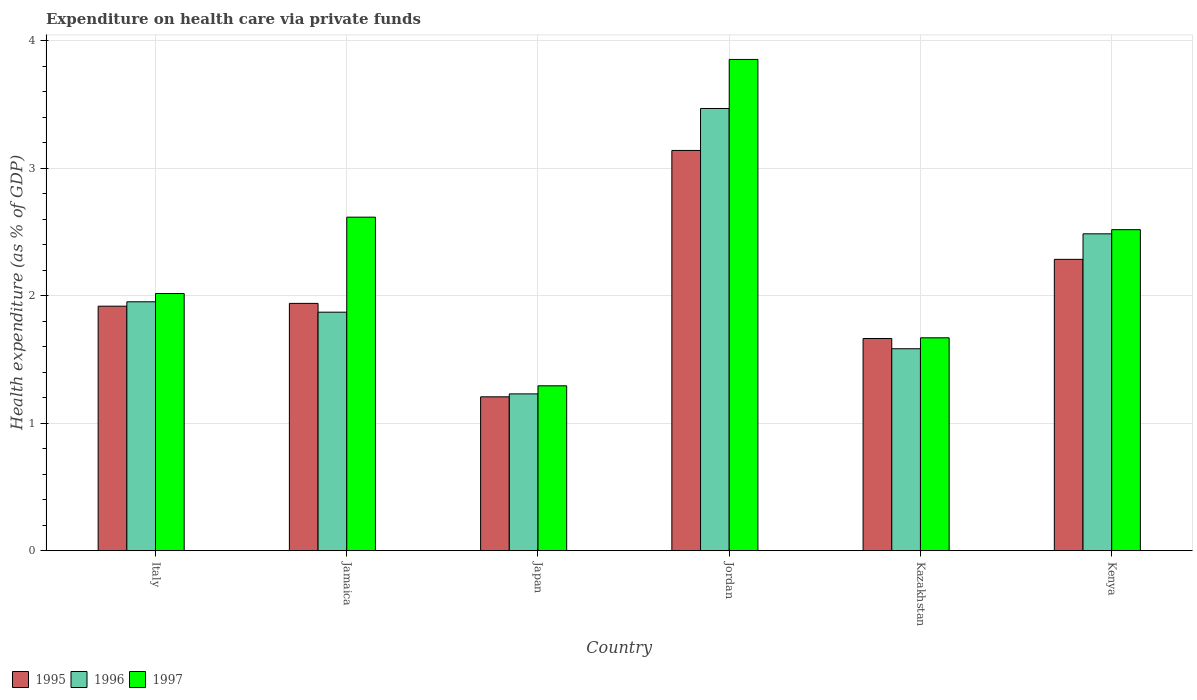Are the number of bars per tick equal to the number of legend labels?
Offer a very short reply. Yes. Are the number of bars on each tick of the X-axis equal?
Provide a succinct answer. Yes. How many bars are there on the 4th tick from the left?
Your response must be concise. 3. What is the label of the 5th group of bars from the left?
Ensure brevity in your answer.  Kazakhstan. What is the expenditure made on health care in 1997 in Kenya?
Ensure brevity in your answer.  2.52. Across all countries, what is the maximum expenditure made on health care in 1995?
Keep it short and to the point. 3.14. Across all countries, what is the minimum expenditure made on health care in 1996?
Provide a short and direct response. 1.23. In which country was the expenditure made on health care in 1997 maximum?
Your answer should be very brief. Jordan. What is the total expenditure made on health care in 1997 in the graph?
Make the answer very short. 13.97. What is the difference between the expenditure made on health care in 1996 in Italy and that in Japan?
Your answer should be compact. 0.72. What is the difference between the expenditure made on health care in 1997 in Kenya and the expenditure made on health care in 1995 in Japan?
Offer a terse response. 1.31. What is the average expenditure made on health care in 1997 per country?
Offer a terse response. 2.33. What is the difference between the expenditure made on health care of/in 1996 and expenditure made on health care of/in 1995 in Jordan?
Offer a very short reply. 0.33. In how many countries, is the expenditure made on health care in 1997 greater than 2.2 %?
Provide a short and direct response. 3. What is the ratio of the expenditure made on health care in 1997 in Italy to that in Jamaica?
Your answer should be very brief. 0.77. Is the expenditure made on health care in 1997 in Italy less than that in Kenya?
Make the answer very short. Yes. Is the difference between the expenditure made on health care in 1996 in Jamaica and Japan greater than the difference between the expenditure made on health care in 1995 in Jamaica and Japan?
Your response must be concise. No. What is the difference between the highest and the second highest expenditure made on health care in 1995?
Give a very brief answer. -0.35. What is the difference between the highest and the lowest expenditure made on health care in 1995?
Keep it short and to the point. 1.93. In how many countries, is the expenditure made on health care in 1995 greater than the average expenditure made on health care in 1995 taken over all countries?
Your answer should be very brief. 2. Is the sum of the expenditure made on health care in 1995 in Jamaica and Japan greater than the maximum expenditure made on health care in 1996 across all countries?
Provide a succinct answer. No. How many bars are there?
Your answer should be compact. 18. Are all the bars in the graph horizontal?
Make the answer very short. No. How many countries are there in the graph?
Keep it short and to the point. 6. Does the graph contain any zero values?
Provide a succinct answer. No. Does the graph contain grids?
Offer a terse response. Yes. How many legend labels are there?
Give a very brief answer. 3. How are the legend labels stacked?
Keep it short and to the point. Horizontal. What is the title of the graph?
Keep it short and to the point. Expenditure on health care via private funds. What is the label or title of the X-axis?
Make the answer very short. Country. What is the label or title of the Y-axis?
Give a very brief answer. Health expenditure (as % of GDP). What is the Health expenditure (as % of GDP) in 1995 in Italy?
Make the answer very short. 1.92. What is the Health expenditure (as % of GDP) in 1996 in Italy?
Your answer should be compact. 1.95. What is the Health expenditure (as % of GDP) of 1997 in Italy?
Your answer should be very brief. 2.02. What is the Health expenditure (as % of GDP) of 1995 in Jamaica?
Provide a short and direct response. 1.94. What is the Health expenditure (as % of GDP) in 1996 in Jamaica?
Offer a very short reply. 1.87. What is the Health expenditure (as % of GDP) in 1997 in Jamaica?
Ensure brevity in your answer.  2.62. What is the Health expenditure (as % of GDP) of 1995 in Japan?
Give a very brief answer. 1.21. What is the Health expenditure (as % of GDP) of 1996 in Japan?
Keep it short and to the point. 1.23. What is the Health expenditure (as % of GDP) in 1997 in Japan?
Keep it short and to the point. 1.29. What is the Health expenditure (as % of GDP) of 1995 in Jordan?
Your answer should be compact. 3.14. What is the Health expenditure (as % of GDP) in 1996 in Jordan?
Make the answer very short. 3.47. What is the Health expenditure (as % of GDP) of 1997 in Jordan?
Provide a succinct answer. 3.85. What is the Health expenditure (as % of GDP) of 1995 in Kazakhstan?
Give a very brief answer. 1.66. What is the Health expenditure (as % of GDP) in 1996 in Kazakhstan?
Keep it short and to the point. 1.58. What is the Health expenditure (as % of GDP) in 1997 in Kazakhstan?
Offer a terse response. 1.67. What is the Health expenditure (as % of GDP) of 1995 in Kenya?
Provide a short and direct response. 2.29. What is the Health expenditure (as % of GDP) in 1996 in Kenya?
Your response must be concise. 2.49. What is the Health expenditure (as % of GDP) of 1997 in Kenya?
Offer a very short reply. 2.52. Across all countries, what is the maximum Health expenditure (as % of GDP) of 1995?
Keep it short and to the point. 3.14. Across all countries, what is the maximum Health expenditure (as % of GDP) of 1996?
Make the answer very short. 3.47. Across all countries, what is the maximum Health expenditure (as % of GDP) in 1997?
Your answer should be compact. 3.85. Across all countries, what is the minimum Health expenditure (as % of GDP) of 1995?
Keep it short and to the point. 1.21. Across all countries, what is the minimum Health expenditure (as % of GDP) in 1996?
Ensure brevity in your answer.  1.23. Across all countries, what is the minimum Health expenditure (as % of GDP) in 1997?
Keep it short and to the point. 1.29. What is the total Health expenditure (as % of GDP) in 1995 in the graph?
Your response must be concise. 12.15. What is the total Health expenditure (as % of GDP) of 1996 in the graph?
Your answer should be compact. 12.59. What is the total Health expenditure (as % of GDP) in 1997 in the graph?
Keep it short and to the point. 13.97. What is the difference between the Health expenditure (as % of GDP) of 1995 in Italy and that in Jamaica?
Ensure brevity in your answer.  -0.02. What is the difference between the Health expenditure (as % of GDP) in 1996 in Italy and that in Jamaica?
Provide a succinct answer. 0.08. What is the difference between the Health expenditure (as % of GDP) in 1997 in Italy and that in Jamaica?
Provide a short and direct response. -0.6. What is the difference between the Health expenditure (as % of GDP) of 1995 in Italy and that in Japan?
Offer a very short reply. 0.71. What is the difference between the Health expenditure (as % of GDP) of 1996 in Italy and that in Japan?
Offer a very short reply. 0.72. What is the difference between the Health expenditure (as % of GDP) of 1997 in Italy and that in Japan?
Your answer should be compact. 0.72. What is the difference between the Health expenditure (as % of GDP) of 1995 in Italy and that in Jordan?
Give a very brief answer. -1.22. What is the difference between the Health expenditure (as % of GDP) in 1996 in Italy and that in Jordan?
Make the answer very short. -1.52. What is the difference between the Health expenditure (as % of GDP) in 1997 in Italy and that in Jordan?
Ensure brevity in your answer.  -1.84. What is the difference between the Health expenditure (as % of GDP) in 1995 in Italy and that in Kazakhstan?
Provide a short and direct response. 0.25. What is the difference between the Health expenditure (as % of GDP) in 1996 in Italy and that in Kazakhstan?
Your answer should be compact. 0.37. What is the difference between the Health expenditure (as % of GDP) in 1997 in Italy and that in Kazakhstan?
Provide a succinct answer. 0.35. What is the difference between the Health expenditure (as % of GDP) of 1995 in Italy and that in Kenya?
Keep it short and to the point. -0.37. What is the difference between the Health expenditure (as % of GDP) of 1996 in Italy and that in Kenya?
Keep it short and to the point. -0.53. What is the difference between the Health expenditure (as % of GDP) of 1997 in Italy and that in Kenya?
Keep it short and to the point. -0.5. What is the difference between the Health expenditure (as % of GDP) of 1995 in Jamaica and that in Japan?
Ensure brevity in your answer.  0.73. What is the difference between the Health expenditure (as % of GDP) of 1996 in Jamaica and that in Japan?
Make the answer very short. 0.64. What is the difference between the Health expenditure (as % of GDP) of 1997 in Jamaica and that in Japan?
Your response must be concise. 1.32. What is the difference between the Health expenditure (as % of GDP) of 1995 in Jamaica and that in Jordan?
Keep it short and to the point. -1.2. What is the difference between the Health expenditure (as % of GDP) in 1996 in Jamaica and that in Jordan?
Offer a very short reply. -1.6. What is the difference between the Health expenditure (as % of GDP) in 1997 in Jamaica and that in Jordan?
Keep it short and to the point. -1.24. What is the difference between the Health expenditure (as % of GDP) in 1995 in Jamaica and that in Kazakhstan?
Keep it short and to the point. 0.28. What is the difference between the Health expenditure (as % of GDP) in 1996 in Jamaica and that in Kazakhstan?
Offer a very short reply. 0.29. What is the difference between the Health expenditure (as % of GDP) in 1997 in Jamaica and that in Kazakhstan?
Provide a succinct answer. 0.95. What is the difference between the Health expenditure (as % of GDP) of 1995 in Jamaica and that in Kenya?
Your answer should be compact. -0.35. What is the difference between the Health expenditure (as % of GDP) of 1996 in Jamaica and that in Kenya?
Keep it short and to the point. -0.61. What is the difference between the Health expenditure (as % of GDP) of 1997 in Jamaica and that in Kenya?
Your response must be concise. 0.1. What is the difference between the Health expenditure (as % of GDP) of 1995 in Japan and that in Jordan?
Your answer should be very brief. -1.93. What is the difference between the Health expenditure (as % of GDP) in 1996 in Japan and that in Jordan?
Ensure brevity in your answer.  -2.24. What is the difference between the Health expenditure (as % of GDP) of 1997 in Japan and that in Jordan?
Your answer should be very brief. -2.56. What is the difference between the Health expenditure (as % of GDP) of 1995 in Japan and that in Kazakhstan?
Provide a short and direct response. -0.46. What is the difference between the Health expenditure (as % of GDP) of 1996 in Japan and that in Kazakhstan?
Offer a terse response. -0.35. What is the difference between the Health expenditure (as % of GDP) of 1997 in Japan and that in Kazakhstan?
Provide a succinct answer. -0.38. What is the difference between the Health expenditure (as % of GDP) in 1995 in Japan and that in Kenya?
Your answer should be compact. -1.08. What is the difference between the Health expenditure (as % of GDP) in 1996 in Japan and that in Kenya?
Your response must be concise. -1.26. What is the difference between the Health expenditure (as % of GDP) in 1997 in Japan and that in Kenya?
Your answer should be compact. -1.22. What is the difference between the Health expenditure (as % of GDP) in 1995 in Jordan and that in Kazakhstan?
Make the answer very short. 1.48. What is the difference between the Health expenditure (as % of GDP) of 1996 in Jordan and that in Kazakhstan?
Provide a short and direct response. 1.88. What is the difference between the Health expenditure (as % of GDP) in 1997 in Jordan and that in Kazakhstan?
Provide a succinct answer. 2.18. What is the difference between the Health expenditure (as % of GDP) in 1995 in Jordan and that in Kenya?
Ensure brevity in your answer.  0.85. What is the difference between the Health expenditure (as % of GDP) in 1996 in Jordan and that in Kenya?
Provide a succinct answer. 0.98. What is the difference between the Health expenditure (as % of GDP) in 1997 in Jordan and that in Kenya?
Ensure brevity in your answer.  1.34. What is the difference between the Health expenditure (as % of GDP) of 1995 in Kazakhstan and that in Kenya?
Give a very brief answer. -0.62. What is the difference between the Health expenditure (as % of GDP) in 1996 in Kazakhstan and that in Kenya?
Provide a short and direct response. -0.9. What is the difference between the Health expenditure (as % of GDP) in 1997 in Kazakhstan and that in Kenya?
Your answer should be very brief. -0.85. What is the difference between the Health expenditure (as % of GDP) of 1995 in Italy and the Health expenditure (as % of GDP) of 1996 in Jamaica?
Provide a succinct answer. 0.05. What is the difference between the Health expenditure (as % of GDP) of 1995 in Italy and the Health expenditure (as % of GDP) of 1997 in Jamaica?
Ensure brevity in your answer.  -0.7. What is the difference between the Health expenditure (as % of GDP) of 1996 in Italy and the Health expenditure (as % of GDP) of 1997 in Jamaica?
Make the answer very short. -0.66. What is the difference between the Health expenditure (as % of GDP) in 1995 in Italy and the Health expenditure (as % of GDP) in 1996 in Japan?
Provide a short and direct response. 0.69. What is the difference between the Health expenditure (as % of GDP) in 1995 in Italy and the Health expenditure (as % of GDP) in 1997 in Japan?
Your response must be concise. 0.62. What is the difference between the Health expenditure (as % of GDP) of 1996 in Italy and the Health expenditure (as % of GDP) of 1997 in Japan?
Make the answer very short. 0.66. What is the difference between the Health expenditure (as % of GDP) in 1995 in Italy and the Health expenditure (as % of GDP) in 1996 in Jordan?
Provide a succinct answer. -1.55. What is the difference between the Health expenditure (as % of GDP) in 1995 in Italy and the Health expenditure (as % of GDP) in 1997 in Jordan?
Give a very brief answer. -1.94. What is the difference between the Health expenditure (as % of GDP) in 1996 in Italy and the Health expenditure (as % of GDP) in 1997 in Jordan?
Your answer should be compact. -1.9. What is the difference between the Health expenditure (as % of GDP) of 1995 in Italy and the Health expenditure (as % of GDP) of 1996 in Kazakhstan?
Give a very brief answer. 0.33. What is the difference between the Health expenditure (as % of GDP) in 1995 in Italy and the Health expenditure (as % of GDP) in 1997 in Kazakhstan?
Your answer should be compact. 0.25. What is the difference between the Health expenditure (as % of GDP) in 1996 in Italy and the Health expenditure (as % of GDP) in 1997 in Kazakhstan?
Provide a succinct answer. 0.28. What is the difference between the Health expenditure (as % of GDP) of 1995 in Italy and the Health expenditure (as % of GDP) of 1996 in Kenya?
Offer a very short reply. -0.57. What is the difference between the Health expenditure (as % of GDP) in 1995 in Italy and the Health expenditure (as % of GDP) in 1997 in Kenya?
Your answer should be very brief. -0.6. What is the difference between the Health expenditure (as % of GDP) in 1996 in Italy and the Health expenditure (as % of GDP) in 1997 in Kenya?
Give a very brief answer. -0.57. What is the difference between the Health expenditure (as % of GDP) of 1995 in Jamaica and the Health expenditure (as % of GDP) of 1996 in Japan?
Your response must be concise. 0.71. What is the difference between the Health expenditure (as % of GDP) in 1995 in Jamaica and the Health expenditure (as % of GDP) in 1997 in Japan?
Your answer should be compact. 0.65. What is the difference between the Health expenditure (as % of GDP) of 1996 in Jamaica and the Health expenditure (as % of GDP) of 1997 in Japan?
Your response must be concise. 0.58. What is the difference between the Health expenditure (as % of GDP) of 1995 in Jamaica and the Health expenditure (as % of GDP) of 1996 in Jordan?
Keep it short and to the point. -1.53. What is the difference between the Health expenditure (as % of GDP) of 1995 in Jamaica and the Health expenditure (as % of GDP) of 1997 in Jordan?
Provide a succinct answer. -1.91. What is the difference between the Health expenditure (as % of GDP) in 1996 in Jamaica and the Health expenditure (as % of GDP) in 1997 in Jordan?
Ensure brevity in your answer.  -1.98. What is the difference between the Health expenditure (as % of GDP) in 1995 in Jamaica and the Health expenditure (as % of GDP) in 1996 in Kazakhstan?
Ensure brevity in your answer.  0.36. What is the difference between the Health expenditure (as % of GDP) in 1995 in Jamaica and the Health expenditure (as % of GDP) in 1997 in Kazakhstan?
Offer a very short reply. 0.27. What is the difference between the Health expenditure (as % of GDP) of 1996 in Jamaica and the Health expenditure (as % of GDP) of 1997 in Kazakhstan?
Ensure brevity in your answer.  0.2. What is the difference between the Health expenditure (as % of GDP) of 1995 in Jamaica and the Health expenditure (as % of GDP) of 1996 in Kenya?
Make the answer very short. -0.55. What is the difference between the Health expenditure (as % of GDP) in 1995 in Jamaica and the Health expenditure (as % of GDP) in 1997 in Kenya?
Offer a terse response. -0.58. What is the difference between the Health expenditure (as % of GDP) of 1996 in Jamaica and the Health expenditure (as % of GDP) of 1997 in Kenya?
Your response must be concise. -0.65. What is the difference between the Health expenditure (as % of GDP) of 1995 in Japan and the Health expenditure (as % of GDP) of 1996 in Jordan?
Provide a short and direct response. -2.26. What is the difference between the Health expenditure (as % of GDP) in 1995 in Japan and the Health expenditure (as % of GDP) in 1997 in Jordan?
Offer a terse response. -2.65. What is the difference between the Health expenditure (as % of GDP) in 1996 in Japan and the Health expenditure (as % of GDP) in 1997 in Jordan?
Your response must be concise. -2.62. What is the difference between the Health expenditure (as % of GDP) of 1995 in Japan and the Health expenditure (as % of GDP) of 1996 in Kazakhstan?
Ensure brevity in your answer.  -0.38. What is the difference between the Health expenditure (as % of GDP) of 1995 in Japan and the Health expenditure (as % of GDP) of 1997 in Kazakhstan?
Ensure brevity in your answer.  -0.46. What is the difference between the Health expenditure (as % of GDP) of 1996 in Japan and the Health expenditure (as % of GDP) of 1997 in Kazakhstan?
Your answer should be very brief. -0.44. What is the difference between the Health expenditure (as % of GDP) of 1995 in Japan and the Health expenditure (as % of GDP) of 1996 in Kenya?
Provide a succinct answer. -1.28. What is the difference between the Health expenditure (as % of GDP) in 1995 in Japan and the Health expenditure (as % of GDP) in 1997 in Kenya?
Offer a very short reply. -1.31. What is the difference between the Health expenditure (as % of GDP) in 1996 in Japan and the Health expenditure (as % of GDP) in 1997 in Kenya?
Your answer should be very brief. -1.29. What is the difference between the Health expenditure (as % of GDP) in 1995 in Jordan and the Health expenditure (as % of GDP) in 1996 in Kazakhstan?
Ensure brevity in your answer.  1.56. What is the difference between the Health expenditure (as % of GDP) of 1995 in Jordan and the Health expenditure (as % of GDP) of 1997 in Kazakhstan?
Your response must be concise. 1.47. What is the difference between the Health expenditure (as % of GDP) in 1996 in Jordan and the Health expenditure (as % of GDP) in 1997 in Kazakhstan?
Ensure brevity in your answer.  1.8. What is the difference between the Health expenditure (as % of GDP) of 1995 in Jordan and the Health expenditure (as % of GDP) of 1996 in Kenya?
Provide a succinct answer. 0.65. What is the difference between the Health expenditure (as % of GDP) of 1995 in Jordan and the Health expenditure (as % of GDP) of 1997 in Kenya?
Offer a terse response. 0.62. What is the difference between the Health expenditure (as % of GDP) of 1996 in Jordan and the Health expenditure (as % of GDP) of 1997 in Kenya?
Your answer should be compact. 0.95. What is the difference between the Health expenditure (as % of GDP) in 1995 in Kazakhstan and the Health expenditure (as % of GDP) in 1996 in Kenya?
Offer a terse response. -0.82. What is the difference between the Health expenditure (as % of GDP) of 1995 in Kazakhstan and the Health expenditure (as % of GDP) of 1997 in Kenya?
Ensure brevity in your answer.  -0.85. What is the difference between the Health expenditure (as % of GDP) of 1996 in Kazakhstan and the Health expenditure (as % of GDP) of 1997 in Kenya?
Your answer should be very brief. -0.93. What is the average Health expenditure (as % of GDP) of 1995 per country?
Provide a succinct answer. 2.03. What is the average Health expenditure (as % of GDP) of 1996 per country?
Keep it short and to the point. 2.1. What is the average Health expenditure (as % of GDP) in 1997 per country?
Provide a short and direct response. 2.33. What is the difference between the Health expenditure (as % of GDP) in 1995 and Health expenditure (as % of GDP) in 1996 in Italy?
Your response must be concise. -0.03. What is the difference between the Health expenditure (as % of GDP) in 1995 and Health expenditure (as % of GDP) in 1997 in Italy?
Make the answer very short. -0.1. What is the difference between the Health expenditure (as % of GDP) of 1996 and Health expenditure (as % of GDP) of 1997 in Italy?
Offer a very short reply. -0.06. What is the difference between the Health expenditure (as % of GDP) in 1995 and Health expenditure (as % of GDP) in 1996 in Jamaica?
Offer a very short reply. 0.07. What is the difference between the Health expenditure (as % of GDP) of 1995 and Health expenditure (as % of GDP) of 1997 in Jamaica?
Your response must be concise. -0.68. What is the difference between the Health expenditure (as % of GDP) of 1996 and Health expenditure (as % of GDP) of 1997 in Jamaica?
Ensure brevity in your answer.  -0.75. What is the difference between the Health expenditure (as % of GDP) in 1995 and Health expenditure (as % of GDP) in 1996 in Japan?
Your answer should be very brief. -0.02. What is the difference between the Health expenditure (as % of GDP) in 1995 and Health expenditure (as % of GDP) in 1997 in Japan?
Your answer should be compact. -0.09. What is the difference between the Health expenditure (as % of GDP) of 1996 and Health expenditure (as % of GDP) of 1997 in Japan?
Your answer should be compact. -0.06. What is the difference between the Health expenditure (as % of GDP) of 1995 and Health expenditure (as % of GDP) of 1996 in Jordan?
Offer a terse response. -0.33. What is the difference between the Health expenditure (as % of GDP) in 1995 and Health expenditure (as % of GDP) in 1997 in Jordan?
Your answer should be very brief. -0.71. What is the difference between the Health expenditure (as % of GDP) of 1996 and Health expenditure (as % of GDP) of 1997 in Jordan?
Offer a terse response. -0.38. What is the difference between the Health expenditure (as % of GDP) of 1995 and Health expenditure (as % of GDP) of 1996 in Kazakhstan?
Make the answer very short. 0.08. What is the difference between the Health expenditure (as % of GDP) of 1995 and Health expenditure (as % of GDP) of 1997 in Kazakhstan?
Give a very brief answer. -0.01. What is the difference between the Health expenditure (as % of GDP) in 1996 and Health expenditure (as % of GDP) in 1997 in Kazakhstan?
Provide a succinct answer. -0.09. What is the difference between the Health expenditure (as % of GDP) in 1995 and Health expenditure (as % of GDP) in 1996 in Kenya?
Provide a succinct answer. -0.2. What is the difference between the Health expenditure (as % of GDP) in 1995 and Health expenditure (as % of GDP) in 1997 in Kenya?
Provide a short and direct response. -0.23. What is the difference between the Health expenditure (as % of GDP) of 1996 and Health expenditure (as % of GDP) of 1997 in Kenya?
Your response must be concise. -0.03. What is the ratio of the Health expenditure (as % of GDP) in 1995 in Italy to that in Jamaica?
Ensure brevity in your answer.  0.99. What is the ratio of the Health expenditure (as % of GDP) of 1996 in Italy to that in Jamaica?
Your response must be concise. 1.04. What is the ratio of the Health expenditure (as % of GDP) of 1997 in Italy to that in Jamaica?
Offer a very short reply. 0.77. What is the ratio of the Health expenditure (as % of GDP) of 1995 in Italy to that in Japan?
Give a very brief answer. 1.59. What is the ratio of the Health expenditure (as % of GDP) of 1996 in Italy to that in Japan?
Your response must be concise. 1.59. What is the ratio of the Health expenditure (as % of GDP) in 1997 in Italy to that in Japan?
Offer a terse response. 1.56. What is the ratio of the Health expenditure (as % of GDP) of 1995 in Italy to that in Jordan?
Your response must be concise. 0.61. What is the ratio of the Health expenditure (as % of GDP) in 1996 in Italy to that in Jordan?
Your answer should be very brief. 0.56. What is the ratio of the Health expenditure (as % of GDP) in 1997 in Italy to that in Jordan?
Your response must be concise. 0.52. What is the ratio of the Health expenditure (as % of GDP) in 1995 in Italy to that in Kazakhstan?
Your answer should be very brief. 1.15. What is the ratio of the Health expenditure (as % of GDP) of 1996 in Italy to that in Kazakhstan?
Offer a very short reply. 1.23. What is the ratio of the Health expenditure (as % of GDP) of 1997 in Italy to that in Kazakhstan?
Your answer should be compact. 1.21. What is the ratio of the Health expenditure (as % of GDP) of 1995 in Italy to that in Kenya?
Your answer should be very brief. 0.84. What is the ratio of the Health expenditure (as % of GDP) in 1996 in Italy to that in Kenya?
Your answer should be compact. 0.79. What is the ratio of the Health expenditure (as % of GDP) of 1997 in Italy to that in Kenya?
Offer a very short reply. 0.8. What is the ratio of the Health expenditure (as % of GDP) of 1995 in Jamaica to that in Japan?
Provide a short and direct response. 1.61. What is the ratio of the Health expenditure (as % of GDP) of 1996 in Jamaica to that in Japan?
Your answer should be compact. 1.52. What is the ratio of the Health expenditure (as % of GDP) in 1997 in Jamaica to that in Japan?
Ensure brevity in your answer.  2.02. What is the ratio of the Health expenditure (as % of GDP) of 1995 in Jamaica to that in Jordan?
Give a very brief answer. 0.62. What is the ratio of the Health expenditure (as % of GDP) in 1996 in Jamaica to that in Jordan?
Provide a short and direct response. 0.54. What is the ratio of the Health expenditure (as % of GDP) of 1997 in Jamaica to that in Jordan?
Ensure brevity in your answer.  0.68. What is the ratio of the Health expenditure (as % of GDP) in 1995 in Jamaica to that in Kazakhstan?
Your answer should be very brief. 1.17. What is the ratio of the Health expenditure (as % of GDP) of 1996 in Jamaica to that in Kazakhstan?
Ensure brevity in your answer.  1.18. What is the ratio of the Health expenditure (as % of GDP) in 1997 in Jamaica to that in Kazakhstan?
Provide a succinct answer. 1.57. What is the ratio of the Health expenditure (as % of GDP) of 1995 in Jamaica to that in Kenya?
Your answer should be very brief. 0.85. What is the ratio of the Health expenditure (as % of GDP) of 1996 in Jamaica to that in Kenya?
Your response must be concise. 0.75. What is the ratio of the Health expenditure (as % of GDP) of 1997 in Jamaica to that in Kenya?
Your response must be concise. 1.04. What is the ratio of the Health expenditure (as % of GDP) in 1995 in Japan to that in Jordan?
Your response must be concise. 0.38. What is the ratio of the Health expenditure (as % of GDP) in 1996 in Japan to that in Jordan?
Keep it short and to the point. 0.35. What is the ratio of the Health expenditure (as % of GDP) of 1997 in Japan to that in Jordan?
Give a very brief answer. 0.34. What is the ratio of the Health expenditure (as % of GDP) of 1995 in Japan to that in Kazakhstan?
Your answer should be compact. 0.73. What is the ratio of the Health expenditure (as % of GDP) in 1996 in Japan to that in Kazakhstan?
Your answer should be compact. 0.78. What is the ratio of the Health expenditure (as % of GDP) of 1997 in Japan to that in Kazakhstan?
Offer a very short reply. 0.77. What is the ratio of the Health expenditure (as % of GDP) of 1995 in Japan to that in Kenya?
Give a very brief answer. 0.53. What is the ratio of the Health expenditure (as % of GDP) of 1996 in Japan to that in Kenya?
Make the answer very short. 0.49. What is the ratio of the Health expenditure (as % of GDP) of 1997 in Japan to that in Kenya?
Ensure brevity in your answer.  0.51. What is the ratio of the Health expenditure (as % of GDP) in 1995 in Jordan to that in Kazakhstan?
Offer a terse response. 1.89. What is the ratio of the Health expenditure (as % of GDP) in 1996 in Jordan to that in Kazakhstan?
Provide a short and direct response. 2.19. What is the ratio of the Health expenditure (as % of GDP) in 1997 in Jordan to that in Kazakhstan?
Your answer should be compact. 2.31. What is the ratio of the Health expenditure (as % of GDP) of 1995 in Jordan to that in Kenya?
Provide a succinct answer. 1.37. What is the ratio of the Health expenditure (as % of GDP) of 1996 in Jordan to that in Kenya?
Ensure brevity in your answer.  1.4. What is the ratio of the Health expenditure (as % of GDP) in 1997 in Jordan to that in Kenya?
Offer a terse response. 1.53. What is the ratio of the Health expenditure (as % of GDP) in 1995 in Kazakhstan to that in Kenya?
Provide a succinct answer. 0.73. What is the ratio of the Health expenditure (as % of GDP) in 1996 in Kazakhstan to that in Kenya?
Give a very brief answer. 0.64. What is the ratio of the Health expenditure (as % of GDP) in 1997 in Kazakhstan to that in Kenya?
Make the answer very short. 0.66. What is the difference between the highest and the second highest Health expenditure (as % of GDP) in 1995?
Offer a very short reply. 0.85. What is the difference between the highest and the second highest Health expenditure (as % of GDP) in 1996?
Your answer should be compact. 0.98. What is the difference between the highest and the second highest Health expenditure (as % of GDP) in 1997?
Offer a terse response. 1.24. What is the difference between the highest and the lowest Health expenditure (as % of GDP) of 1995?
Give a very brief answer. 1.93. What is the difference between the highest and the lowest Health expenditure (as % of GDP) of 1996?
Keep it short and to the point. 2.24. What is the difference between the highest and the lowest Health expenditure (as % of GDP) of 1997?
Ensure brevity in your answer.  2.56. 